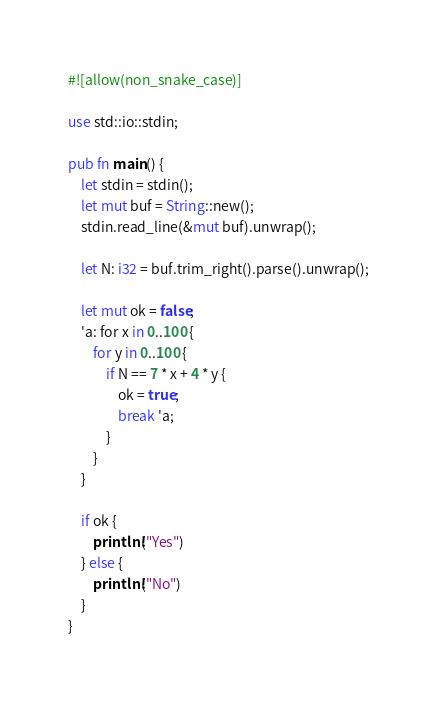Convert code to text. <code><loc_0><loc_0><loc_500><loc_500><_Rust_>#![allow(non_snake_case)]

use std::io::stdin;

pub fn main() {
    let stdin = stdin();
    let mut buf = String::new();
    stdin.read_line(&mut buf).unwrap();

    let N: i32 = buf.trim_right().parse().unwrap();

    let mut ok = false;
    'a: for x in 0..100 {
        for y in 0..100 {
            if N == 7 * x + 4 * y {
                ok = true;
                break 'a;
            }
        }
    }

    if ok {
        println!("Yes")
    } else {
        println!("No")
    }
}
</code> 